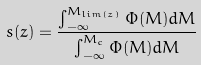Convert formula to latex. <formula><loc_0><loc_0><loc_500><loc_500>s ( z ) = \frac { \int ^ { M _ { l i m ( z ) } } _ { - \infty } \Phi ( M ) d M } { \int ^ { M _ { c } } _ { - \infty } \Phi ( M ) d M }</formula> 